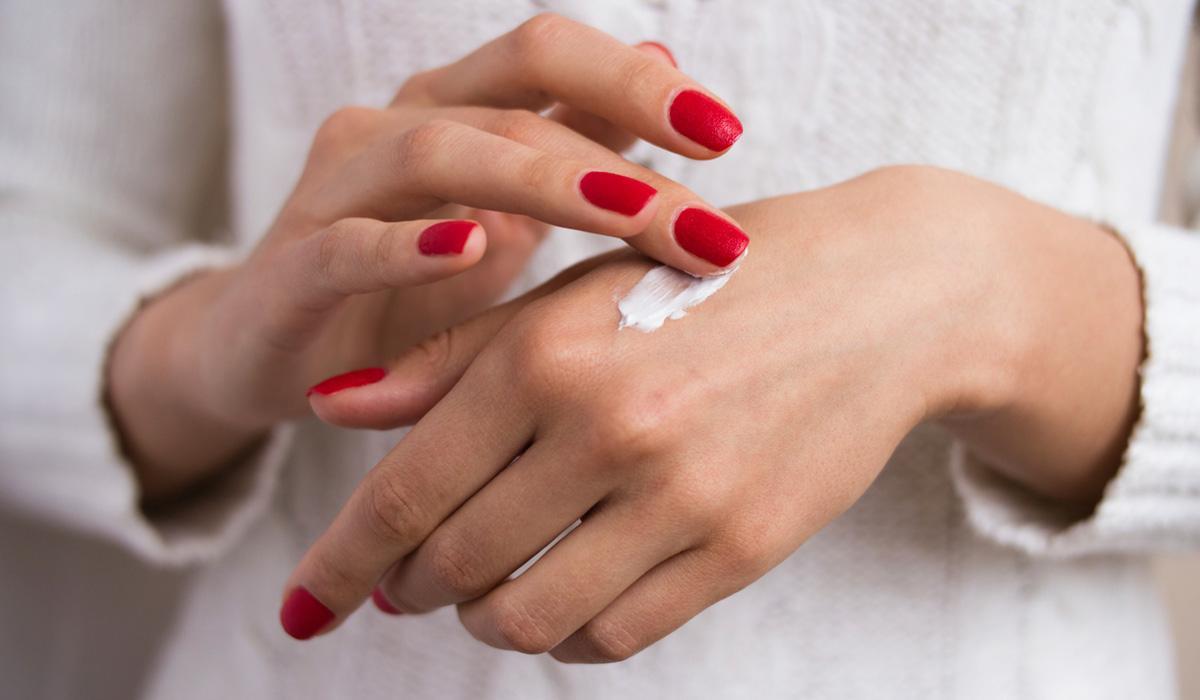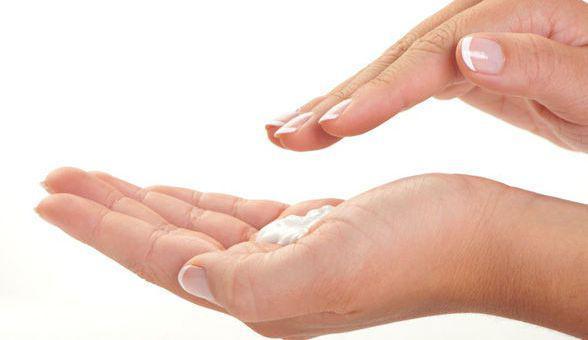The first image is the image on the left, the second image is the image on the right. Considering the images on both sides, is "The left and right image contains a total of four hands with lotion being rubbed on the back of one hand." valid? Answer yes or no. Yes. The first image is the image on the left, the second image is the image on the right. For the images displayed, is the sentence "In one of the images, one hand has a glob of white lotion in the palm." factually correct? Answer yes or no. Yes. 